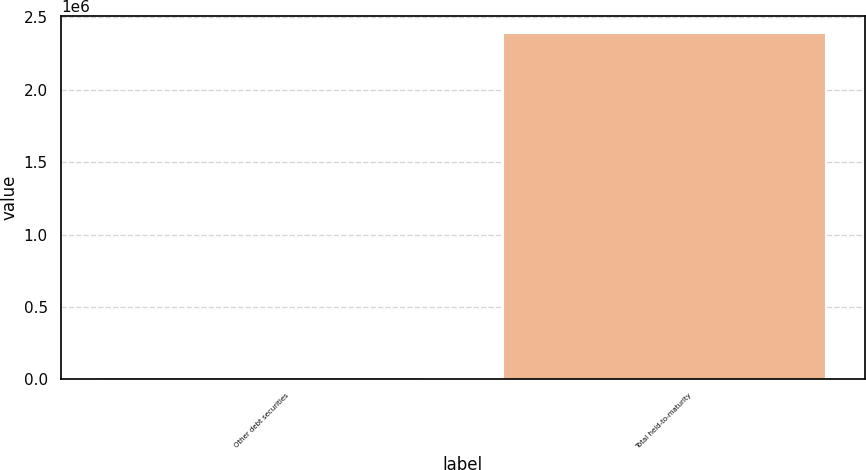<chart> <loc_0><loc_0><loc_500><loc_500><bar_chart><fcel>Other debt securities<fcel>Total held-to-maturity<nl><fcel>12195<fcel>2.38982e+06<nl></chart> 